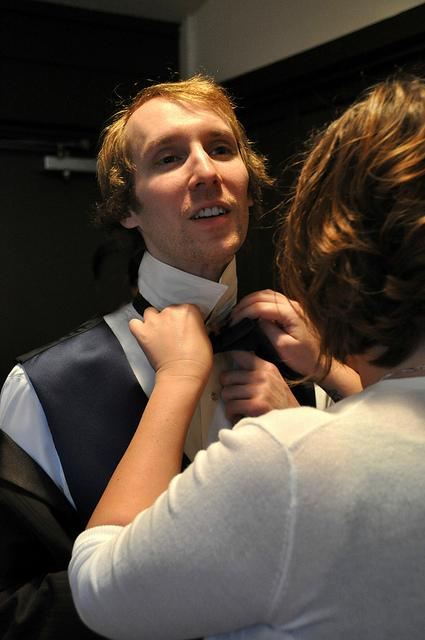What is the woman adjusting?

Choices:
A) her shoelaces
B) cats leash
C) dogs collar
D) tie tie 